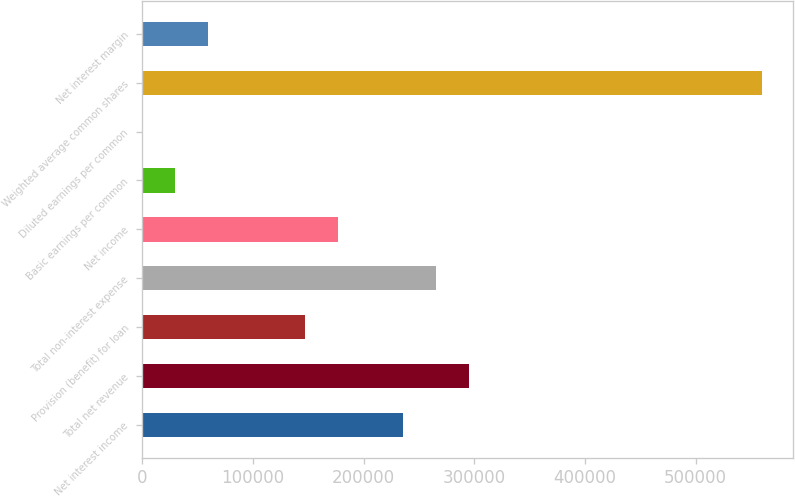Convert chart to OTSL. <chart><loc_0><loc_0><loc_500><loc_500><bar_chart><fcel>Net interest income<fcel>Total net revenue<fcel>Provision (benefit) for loan<fcel>Total non-interest expense<fcel>Net income<fcel>Basic earnings per common<fcel>Diluted earnings per common<fcel>Weighted average common shares<fcel>Net interest margin<nl><fcel>236009<fcel>295011<fcel>147506<fcel>265510<fcel>177007<fcel>29501.9<fcel>0.91<fcel>560520<fcel>59002.9<nl></chart> 